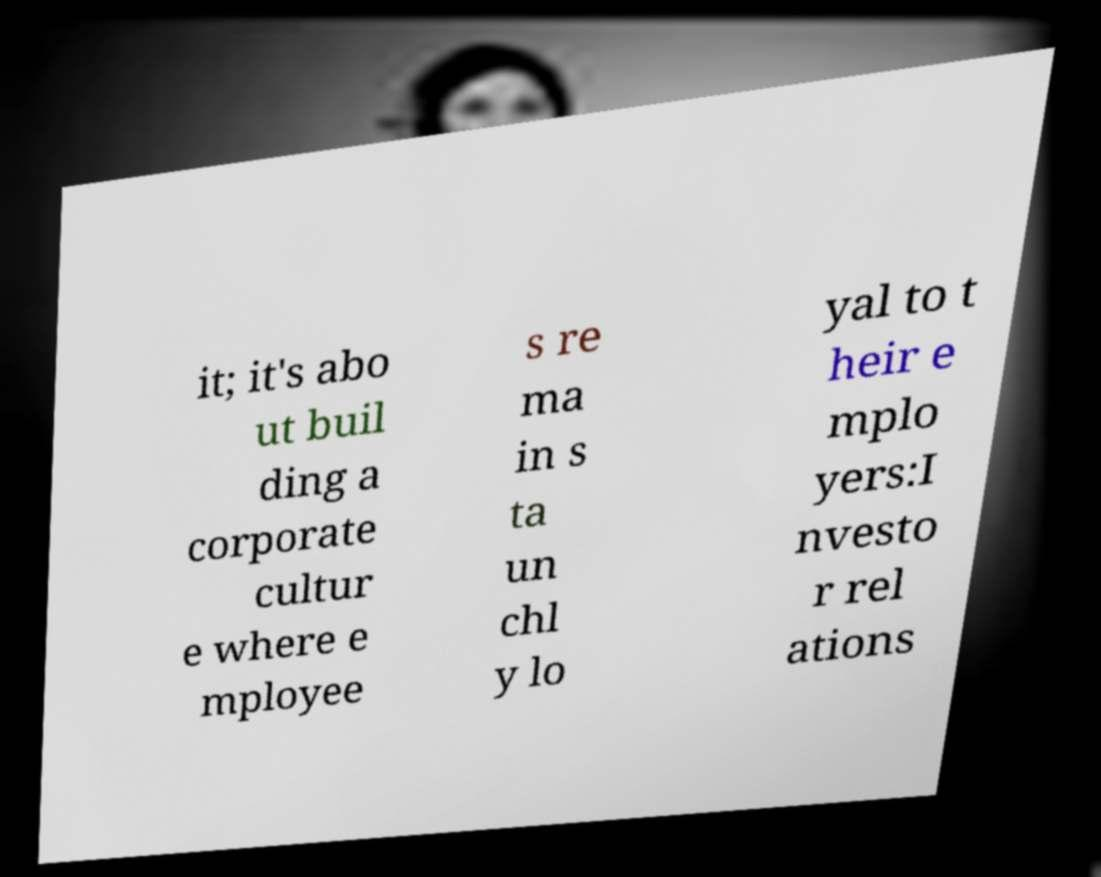Please identify and transcribe the text found in this image. it; it's abo ut buil ding a corporate cultur e where e mployee s re ma in s ta un chl y lo yal to t heir e mplo yers:I nvesto r rel ations 